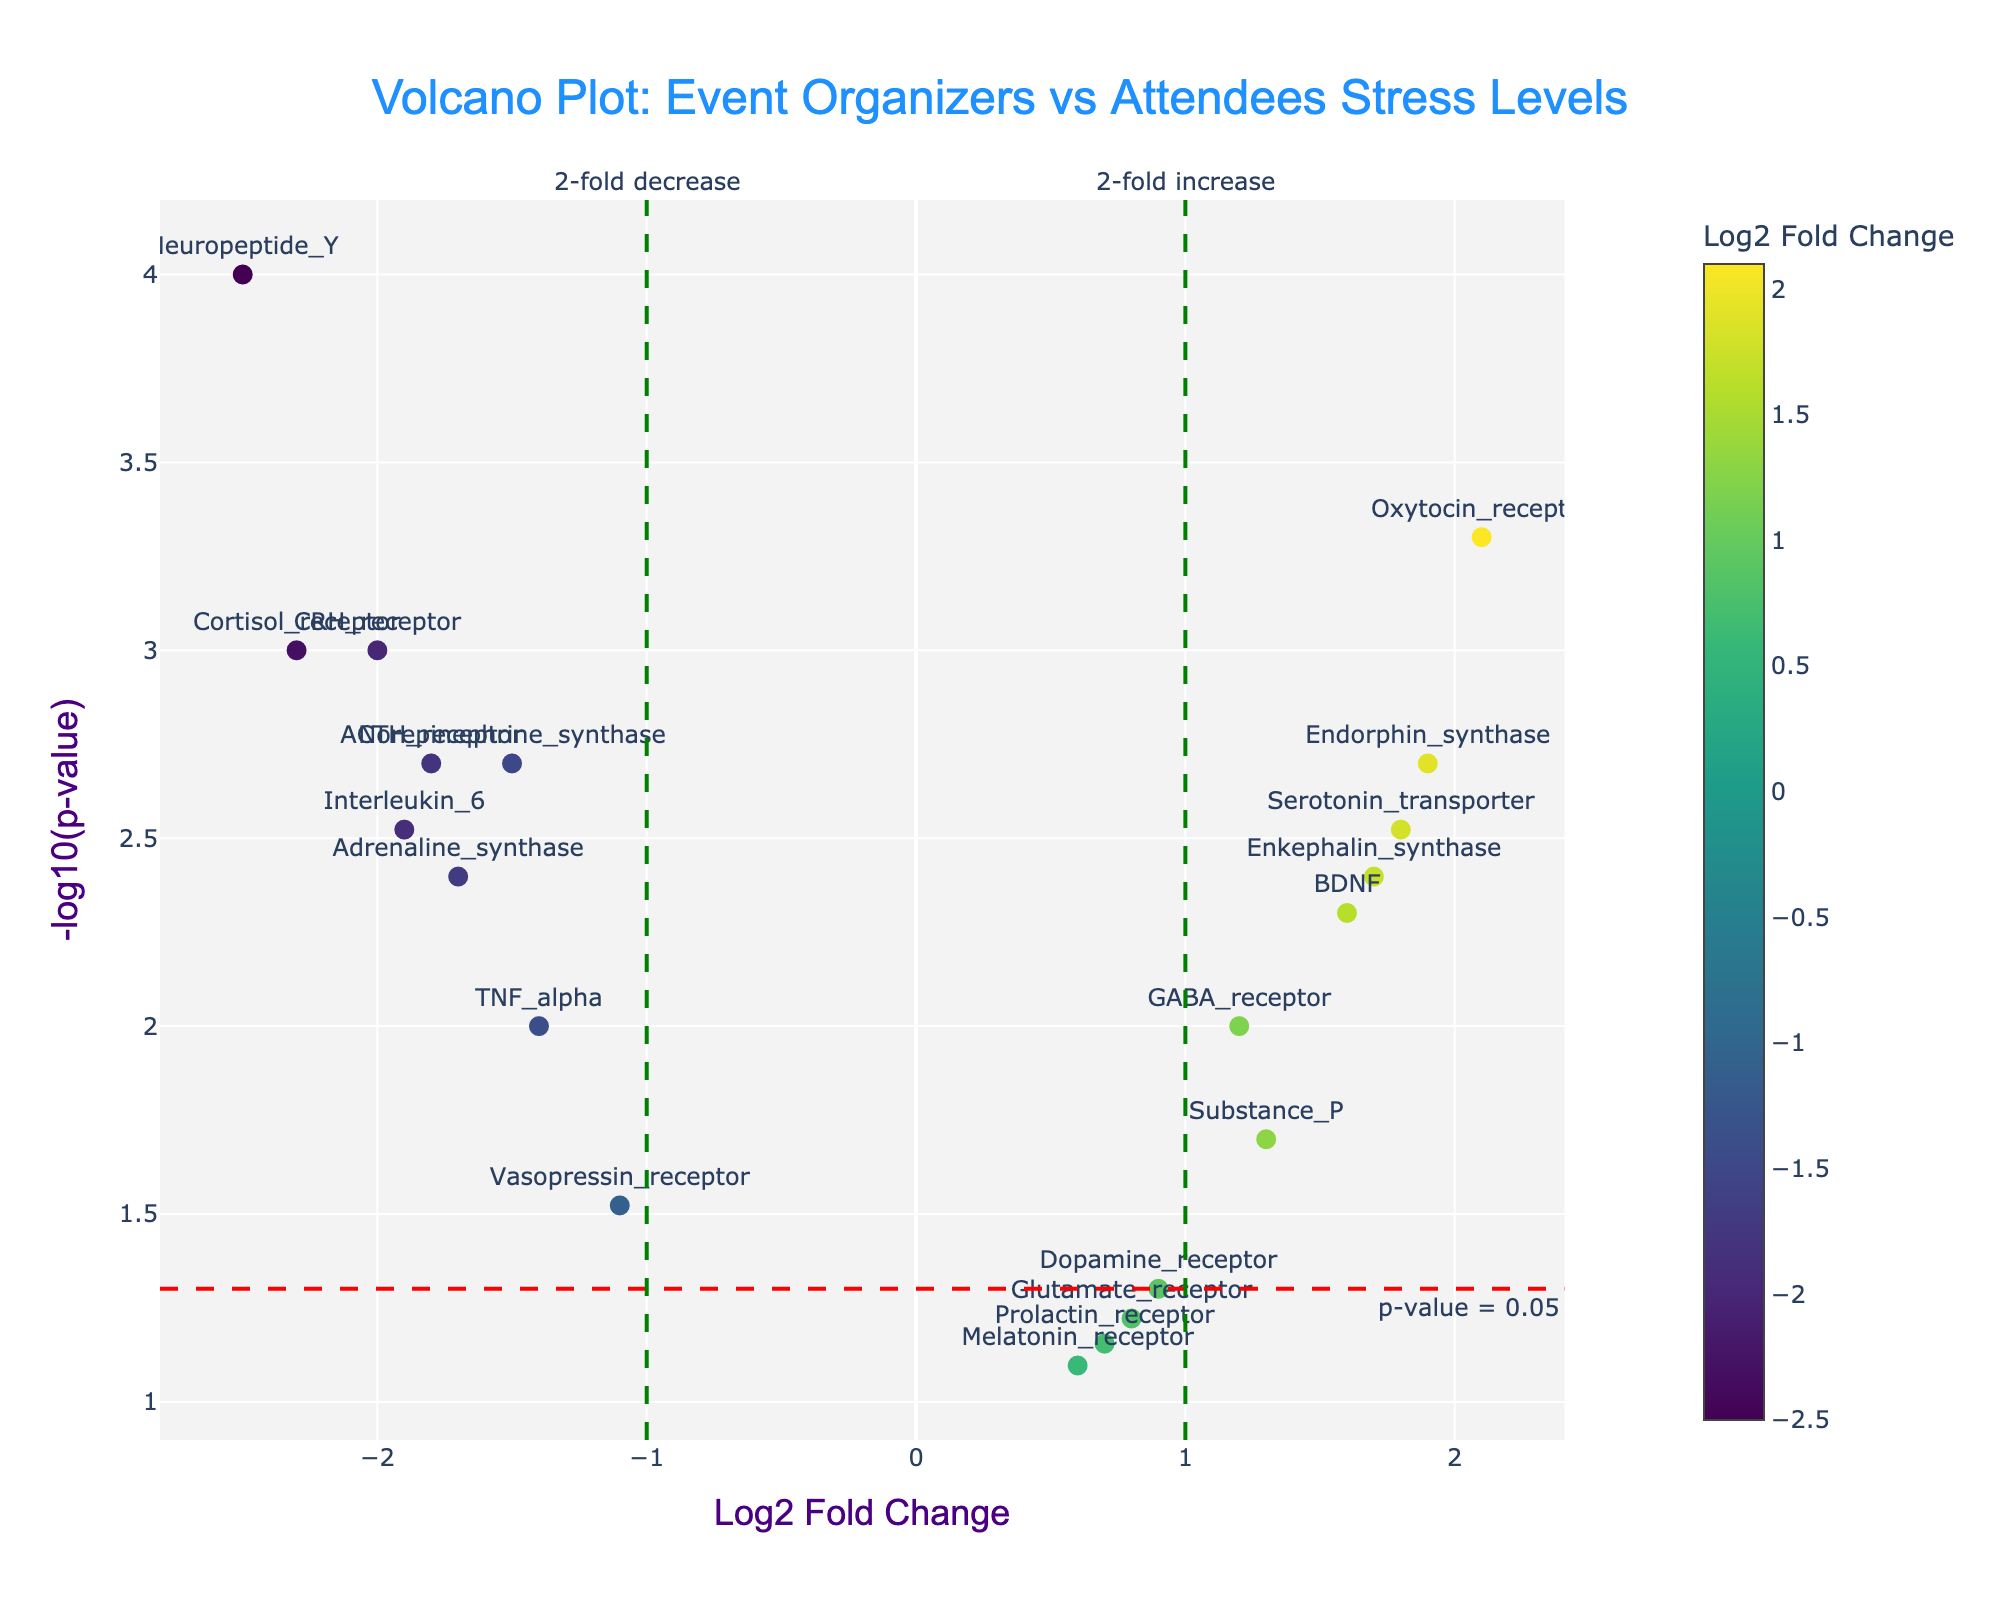What is the title of the plot? The title is shown at the top of the figure and is in bold. The title reads "Volcano Plot: Event Organizers vs Attendees Stress Levels".
Answer: Volcano Plot: Event Organizers vs Attendees Stress Levels What do the x and y axes represent in this plot? The x-axis title reads "Log2 Fold Change" and the y-axis title reads "-log10(p-value)". The x-axis represents the fold change in gene expression between event organizers and attendees, and the y-axis represents the significance level of that change.
Answer: Log2 Fold Change and -log10(p-value) Which gene shows the highest significance level? By identifying the gene with the highest y-value (the highest -log10(p-value)), the gene "Neuropeptide_Y" stands out as having the highest significance level.
Answer: Neuropeptide_Y How many genes show at least a 2-fold change in either direction? The 2-fold change in either direction corresponds to the lines at -1 and 1 on the x-axis. Any points outside these lines represent genes with at least a 2-fold change. Counting these points gives the result.
Answer: 9 genes Which gene has the largest increase in expression? The largest increase in expression can be identified by the highest x-value (log2FoldChange). "Oxytocin_receptor" has the largest log2FoldChange at 2.1.
Answer: Oxytocin_receptor Are there any genes with a significant decrease in expression? If so, name one. A significant decrease in expression can be identified by a negative log2FoldChange and a high y-value indicating significance. One example is "Cortisol_receptor" with a log2FoldChange of -2.3 and a significant p-value.
Answer: Cortisol_receptor What is the significance threshold indicated by a horizontal line? The horizontal line represents a p-value threshold and is labeled as "p-value = 0.05". The corresponding y-value is -log10(0.05), which is roughly 1.3.
Answer: -log10(0.05) or 1.3 How many genes are above the significance threshold but show less than a 2-fold change? Genes above the significance threshold have y-values greater than 1.3 but fall within the x-values between -1 and 1. Counting these points gives the result.
Answer: 4 genes Which genes are below the significance threshold despite showing at least a 2-fold change? Below the significance threshold means having a y-value less than 1.3. Checking the points with x-values less than -1 or greater than 1, "GABA_receptor" appears.
Answer: GABA_receptor What color scale is used to represent Log2 Fold Change in the plot? The plot uses a "Viridis" color scale to represent the Log2 Fold Change. This is described in the hover text and visual color bar.
Answer: Viridis 